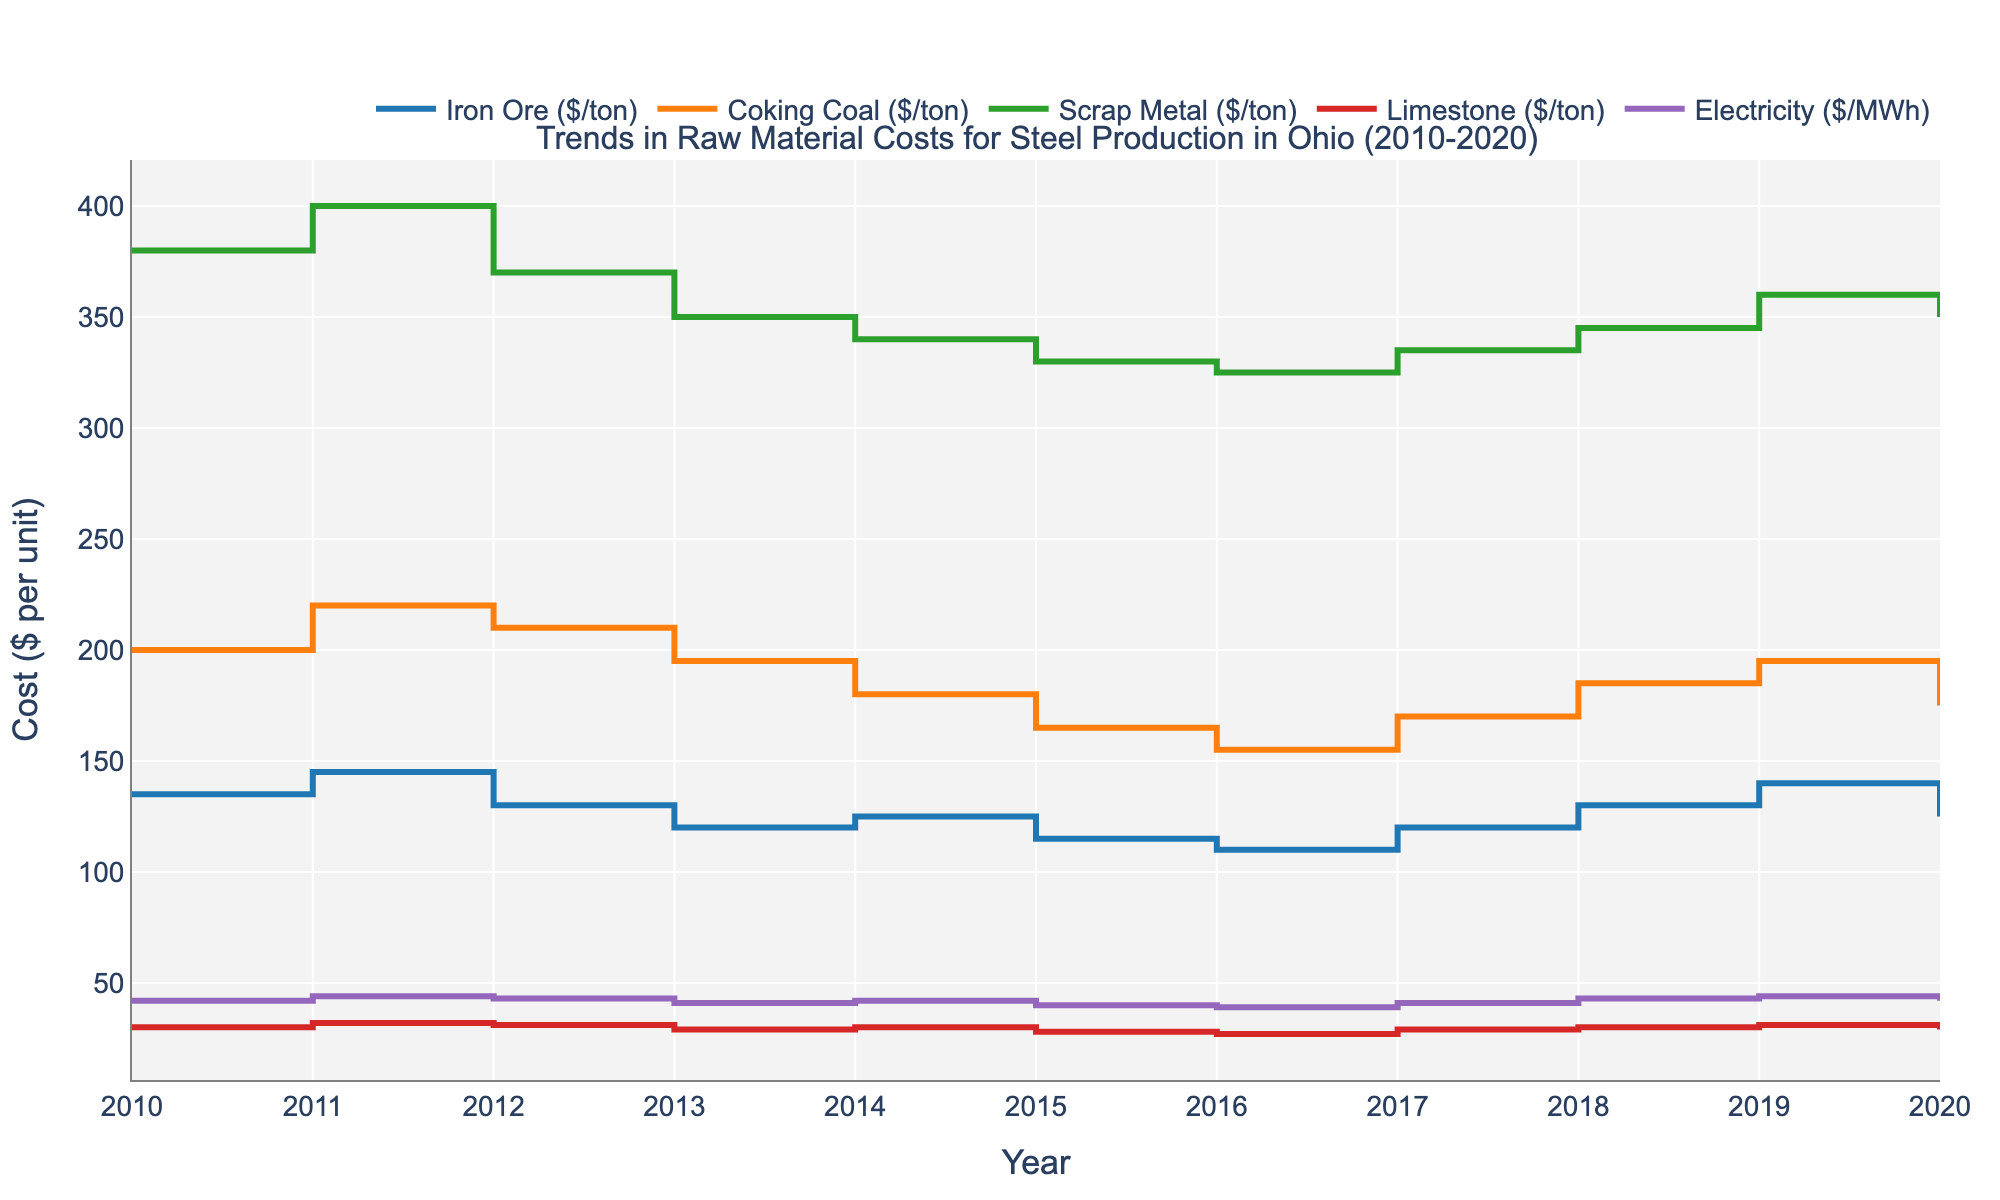What is the title of the plot? The title of the plot is displayed prominently at the top of the chart. It reads "Trends in Raw Material Costs for Steel Production in Ohio (2010-2020)".
Answer: Trends in Raw Material Costs for Steel Production in Ohio (2010-2020) Which raw material had the highest cost in 2010? By looking at the starting point of each line on the left side of the plot, we see that Coking Coal had the highest cost in 2010. Its line starts higher than the others.
Answer: Coking Coal Did the cost of Iron Ore ever exceed $140 per ton during the given period? Observing the Iron Ore line, it reaches and remains above $140 per ton during 2011 and 2019, therefore it exceeded $140 per ton during this period.
Answer: Yes Which raw material had the most consistent cost over the years? Consistency can be judged by how flat the line is over the years. The line representing Limestone is the flattest, indicating the most consistent costs.
Answer: Limestone What year had the lowest cost for Coking Coal? By following the line for Coking Coal, we see that the lowest point occurs in 2016.
Answer: 2016 How did the cost of Scrap Metal change from 2015 to 2017? The line for Scrap Metal starts at $330 per ton in 2015, rises to $335 per ton in 2017. This suggests a gradual increase over these years.
Answer: Increased Which raw materials had a price drop from 2019 to 2020? Checking the end points for each line in 2019 and 2020, we see a drop for Iron Ore, Coking Coal, and Scrap Metal.
Answer: Iron Ore, Coking Coal, Scrap Metal What was the average cost of Electricity in 2015, 2016, and 2017? Averaging the values for Electricity in these years: (40 + 39 + 41) / 3 = 40.
Answer: 40 Between which two consecutive years did Iron Ore experience the greatest drop in cost? Looking at the Iron Ore line, the most significant drop appears between 2011 and 2012, from $145 per ton to $130 per ton, a difference of $15 per ton.
Answer: 2011 and 2012 What was the overall trend for Coking Coal costs from 2010 to 2020? Evaluating the start and end points of the Coking Coal line, it starts high in 2010 and generally declines to 2020, indicating a downward trend.
Answer: Downward 